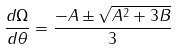Convert formula to latex. <formula><loc_0><loc_0><loc_500><loc_500>\frac { d \Omega } { d \theta } = \frac { - A \pm \sqrt { A ^ { 2 } + 3 B } } { 3 }</formula> 